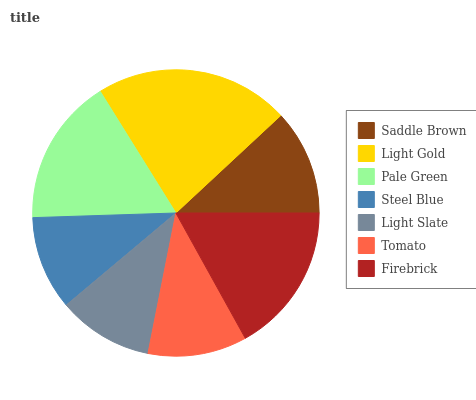Is Steel Blue the minimum?
Answer yes or no. Yes. Is Light Gold the maximum?
Answer yes or no. Yes. Is Pale Green the minimum?
Answer yes or no. No. Is Pale Green the maximum?
Answer yes or no. No. Is Light Gold greater than Pale Green?
Answer yes or no. Yes. Is Pale Green less than Light Gold?
Answer yes or no. Yes. Is Pale Green greater than Light Gold?
Answer yes or no. No. Is Light Gold less than Pale Green?
Answer yes or no. No. Is Saddle Brown the high median?
Answer yes or no. Yes. Is Saddle Brown the low median?
Answer yes or no. Yes. Is Firebrick the high median?
Answer yes or no. No. Is Steel Blue the low median?
Answer yes or no. No. 